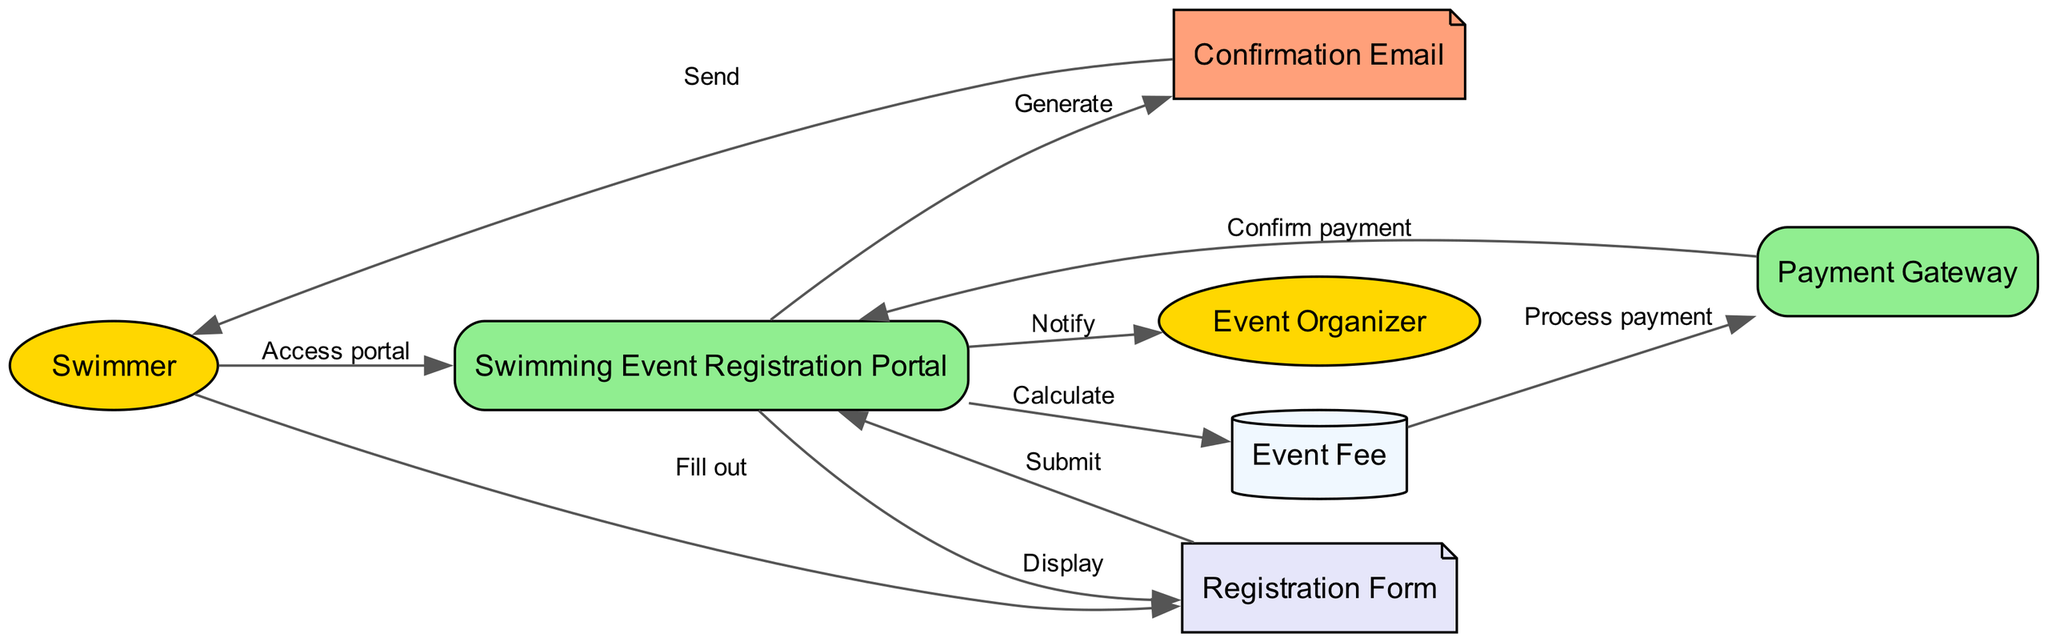What is the first action taken by the Swimmer? The first action taken by the Swimmer is to access the Swimming Event Registration Portal, which is indicated as the initial edge leaving the Swimmer node to the Swimming Event Registration Portal node.
Answer: Access portal How many actors are present in the diagram? There are two actors present in the diagram: Swimmer and Event Organizer, which can be counted by identifying the nodes labeled as Actors.
Answer: Two What does the Swimming Event Registration Portal do after receiving the Registration Form? After receiving the Registration Form, the Swimming Event Registration Portal submits it, as indicated by the edge connecting the Registration Form back to the Swimming Event Registration Portal.
Answer: Submit What signal does the Payment Gateway send back to the Swimming Event Registration Portal? The Payment Gateway sends a confirmation back to the Swimming Event Registration Portal, indicated by the edge connecting the Payment Gateway to the Swimming Event Registration Portal labeled "Confirm payment."
Answer: Confirm payment Which notification is sent to the Swimmer after the payment process? A Confirmation Email is sent to the Swimmer after the payment process, as depicted by the final edge leading from the Confirmation Email to the Swimmer.
Answer: Confirmation Email What happens just before the Swimmer receives the Confirmation Email? Just before the Swimmer receives the Confirmation Email, the Swimming Event Registration Portal generates the email, which is shown in the edge connecting the Swimming Event Registration Portal to the Confirmation Email labeled "Generate."
Answer: Generate What does the Swimming Event Registration Portal do with the Event Fee? The Swimming Event Registration Portal processes the Event Fee, as shown by the edge pointing from the Event Fee to the Payment Gateway labeled "Process payment."
Answer: Process payment How many edges are there in the diagram? The diagram contains eight edges, and this can be counted by enumerating all the connections or edges present between the various nodes in the diagram.
Answer: Eight 